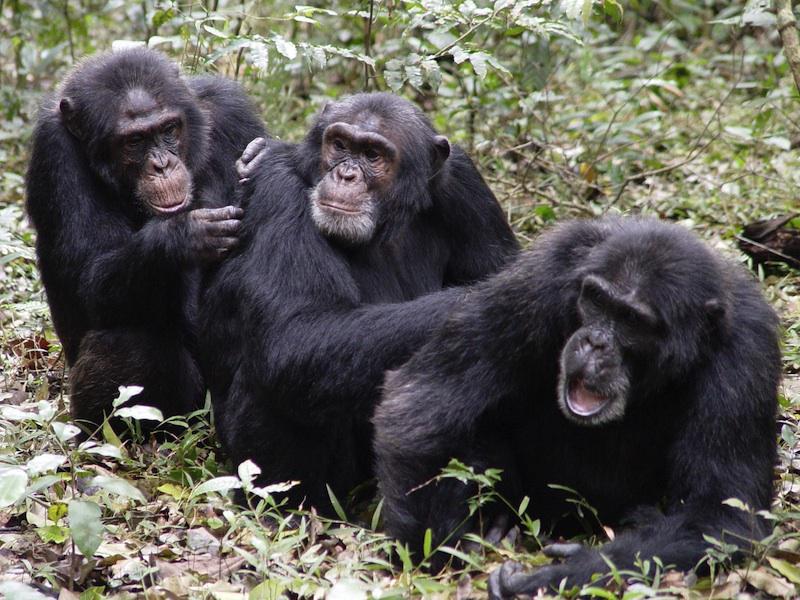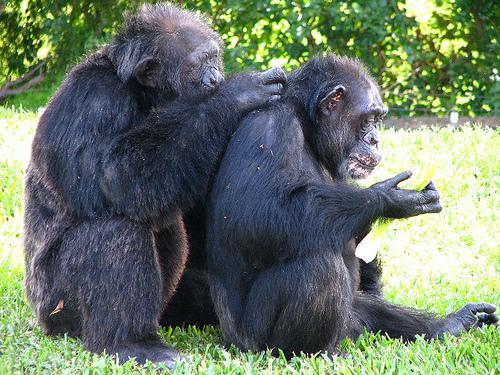The first image is the image on the left, the second image is the image on the right. Evaluate the accuracy of this statement regarding the images: "An image shows two rightward-facing apes, with one sitting behind the other.". Is it true? Answer yes or no. Yes. The first image is the image on the left, the second image is the image on the right. Assess this claim about the two images: "There are exactly three gorillas huddled together in the image on the left.". Correct or not? Answer yes or no. Yes. 